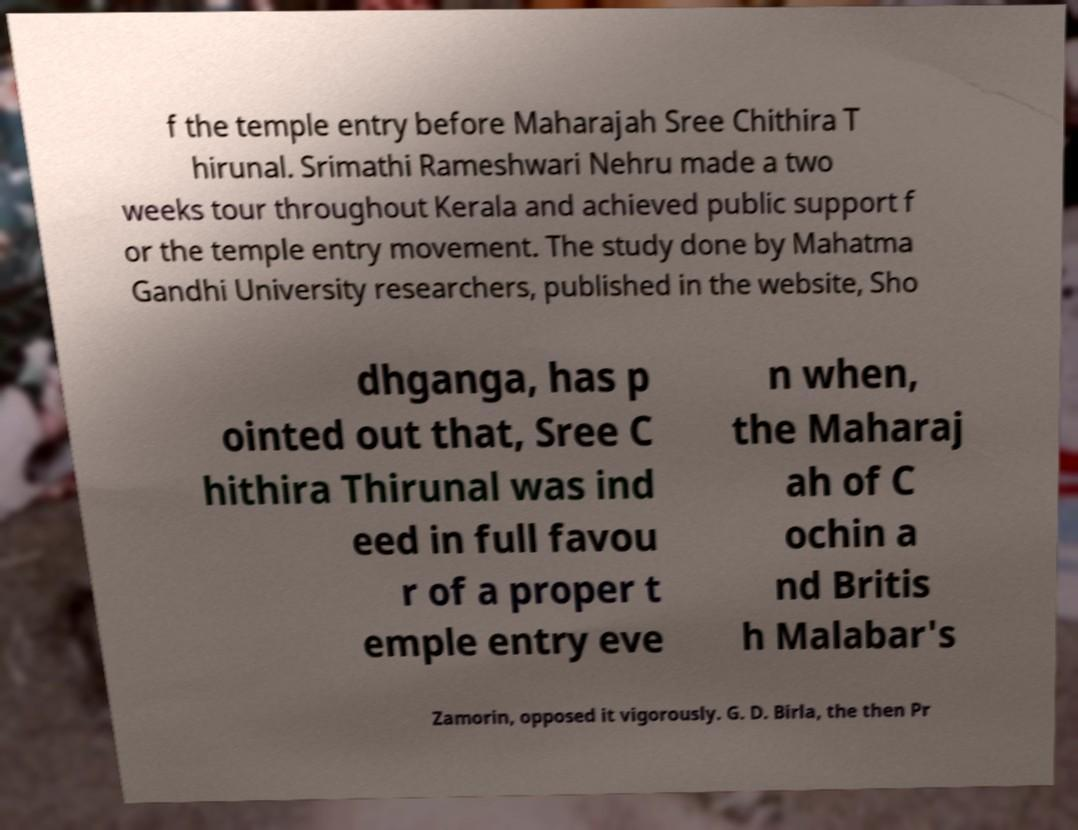Could you assist in decoding the text presented in this image and type it out clearly? f the temple entry before Maharajah Sree Chithira T hirunal. Srimathi Rameshwari Nehru made a two weeks tour throughout Kerala and achieved public support f or the temple entry movement. The study done by Mahatma Gandhi University researchers, published in the website, Sho dhganga, has p ointed out that, Sree C hithira Thirunal was ind eed in full favou r of a proper t emple entry eve n when, the Maharaj ah of C ochin a nd Britis h Malabar's Zamorin, opposed it vigorously. G. D. Birla, the then Pr 